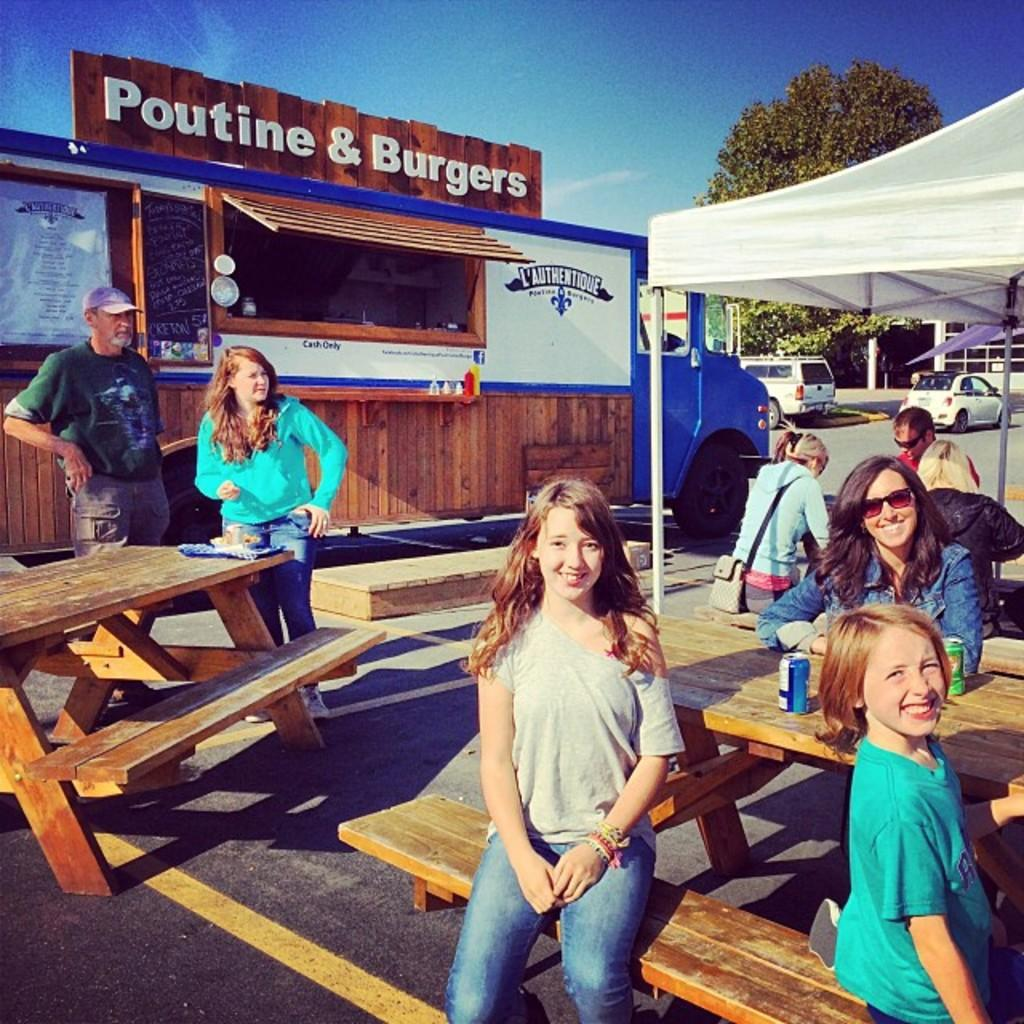How many people are in the image? There is a group of people in the image. What are the people doing in the image? The people are sitting on benches. What is located at the left side of the image? There is a canteen at the left side of the image. Are there any firemen in the garden shown in the image? There is no garden or firemen present in the image. 